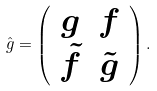Convert formula to latex. <formula><loc_0><loc_0><loc_500><loc_500>\hat { g } = \left ( \begin{array} { c c } g & f \\ \tilde { f } & \tilde { g } \end{array} \right ) .</formula> 